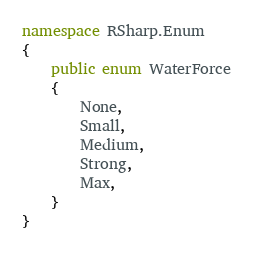<code> <loc_0><loc_0><loc_500><loc_500><_C#_>namespace RSharp.Enum
{
	public enum WaterForce
	{
		None,
		Small,
		Medium,
		Strong,
		Max,
	}
}</code> 